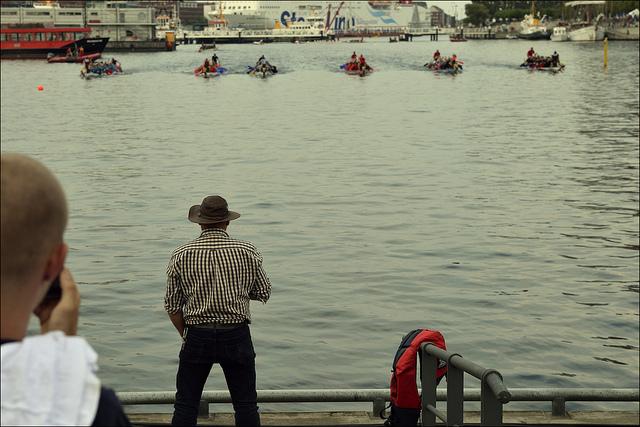Is the man with the hat a cowboy?
Write a very short answer. No. How many boats are in the water?
Write a very short answer. 7. Are the boats moving toward the man in the hat?
Concise answer only. Yes. 